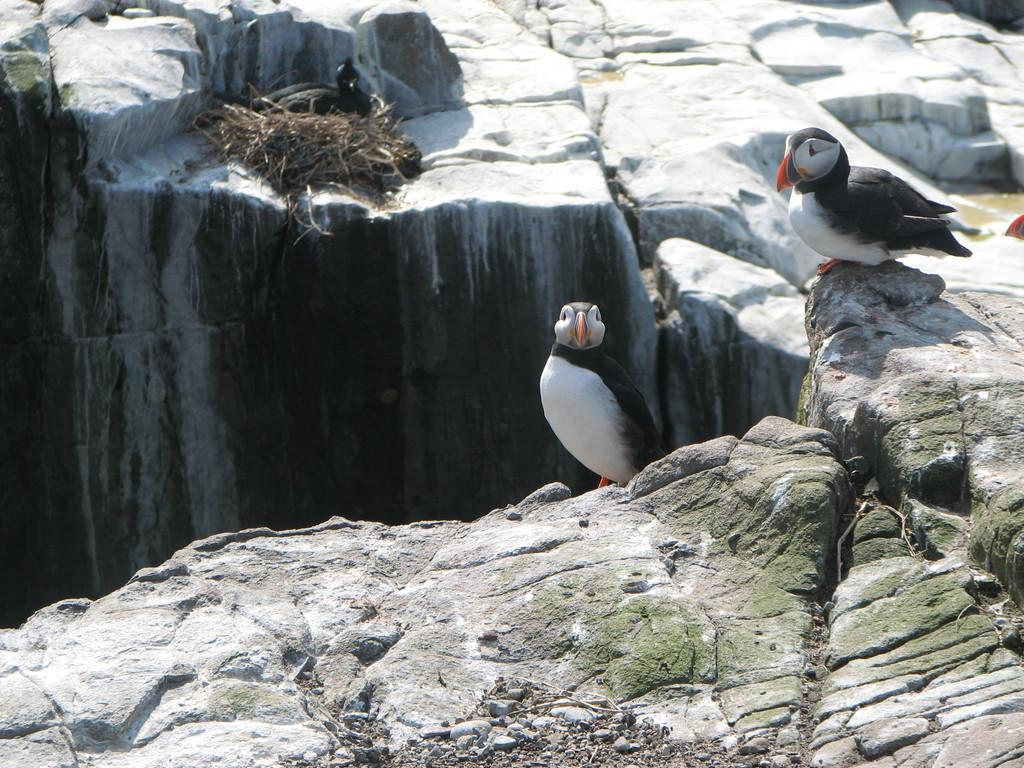What type of animals can be seen in the image? Birds can be seen in the image. What is located at the bottom of the image? There are rocks at the bottom of the image. Can you describe the bird sitting in the image? A black color bird is sitting in the image. What room is the bird in, and how does it feel about being there? There is no room present in the image, as it appears to be an outdoor scene. The bird's feelings cannot be determined from the image. 